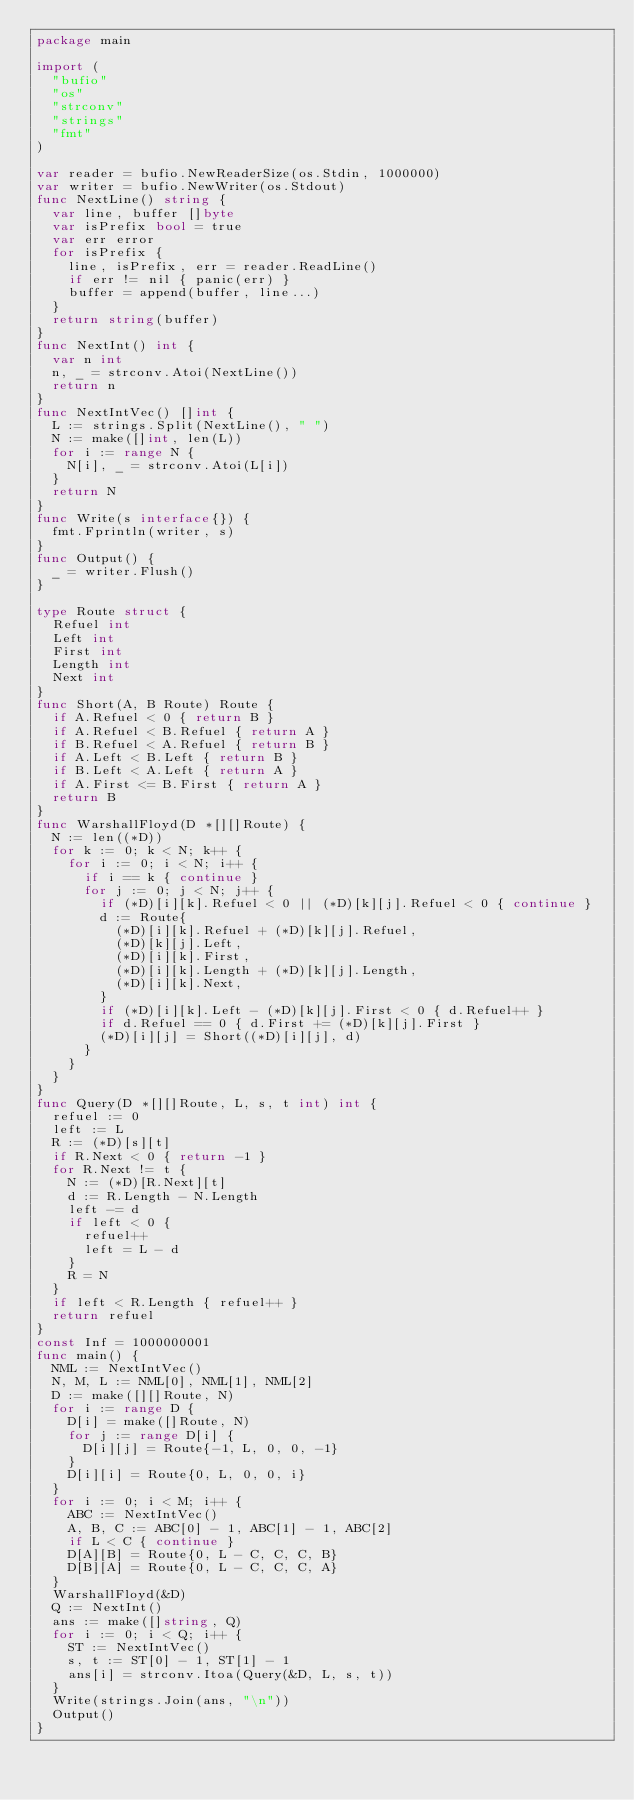Convert code to text. <code><loc_0><loc_0><loc_500><loc_500><_Go_>package main
 
import (
  "bufio"
  "os"
  "strconv"
  "strings"
  "fmt"
)

var reader = bufio.NewReaderSize(os.Stdin, 1000000)
var writer = bufio.NewWriter(os.Stdout)
func NextLine() string {
  var line, buffer []byte
  var isPrefix bool = true
  var err error
  for isPrefix {
    line, isPrefix, err = reader.ReadLine()
    if err != nil { panic(err) }
    buffer = append(buffer, line...)
  }
  return string(buffer)
}
func NextInt() int {
  var n int
  n, _ = strconv.Atoi(NextLine())
  return n
}
func NextIntVec() []int {
  L := strings.Split(NextLine(), " ")
  N := make([]int, len(L))
  for i := range N {
    N[i], _ = strconv.Atoi(L[i])
  }
  return N
}
func Write(s interface{}) {
  fmt.Fprintln(writer, s)
}
func Output() {
  _ = writer.Flush()
}

type Route struct {
  Refuel int
  Left int
  First int
  Length int
  Next int
}
func Short(A, B Route) Route {
  if A.Refuel < 0 { return B }
  if A.Refuel < B.Refuel { return A }
  if B.Refuel < A.Refuel { return B }
  if A.Left < B.Left { return B }
  if B.Left < A.Left { return A }
  if A.First <= B.First { return A }
  return B
}
func WarshallFloyd(D *[][]Route) {
  N := len((*D))
  for k := 0; k < N; k++ {
    for i := 0; i < N; i++ {
      if i == k { continue }
      for j := 0; j < N; j++ {
        if (*D)[i][k].Refuel < 0 || (*D)[k][j].Refuel < 0 { continue }
        d := Route{
          (*D)[i][k].Refuel + (*D)[k][j].Refuel,
          (*D)[k][j].Left,
          (*D)[i][k].First,
          (*D)[i][k].Length + (*D)[k][j].Length,
          (*D)[i][k].Next,
        }
        if (*D)[i][k].Left - (*D)[k][j].First < 0 { d.Refuel++ }
        if d.Refuel == 0 { d.First += (*D)[k][j].First } 
        (*D)[i][j] = Short((*D)[i][j], d)
      }
    }
  }
}
func Query(D *[][]Route, L, s, t int) int {
  refuel := 0
  left := L
  R := (*D)[s][t]
  if R.Next < 0 { return -1 }
  for R.Next != t {
    N := (*D)[R.Next][t]
    d := R.Length - N.Length
    left -= d
    if left < 0 {
      refuel++
      left = L - d
    }
    R = N
  }
  if left < R.Length { refuel++ }
  return refuel
}
const Inf = 1000000001
func main() {
  NML := NextIntVec()
  N, M, L := NML[0], NML[1], NML[2]
  D := make([][]Route, N)
  for i := range D {
    D[i] = make([]Route, N)
    for j := range D[i] {
      D[i][j] = Route{-1, L, 0, 0, -1}
    }
    D[i][i] = Route{0, L, 0, 0, i}
  }
  for i := 0; i < M; i++ {
    ABC := NextIntVec()
    A, B, C := ABC[0] - 1, ABC[1] - 1, ABC[2]
    if L < C { continue }
    D[A][B] = Route{0, L - C, C, C, B}
    D[B][A] = Route{0, L - C, C, C, A}
  }
  WarshallFloyd(&D)
  Q := NextInt()
  ans := make([]string, Q)
  for i := 0; i < Q; i++ {
    ST := NextIntVec()
    s, t := ST[0] - 1, ST[1] - 1
    ans[i] = strconv.Itoa(Query(&D, L, s, t))
  }
  Write(strings.Join(ans, "\n"))
  Output()
}</code> 